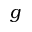<formula> <loc_0><loc_0><loc_500><loc_500>g</formula> 